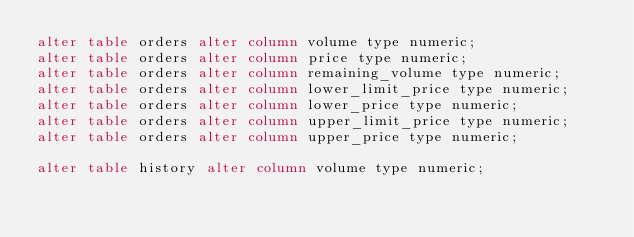Convert code to text. <code><loc_0><loc_0><loc_500><loc_500><_SQL_>alter table orders alter column volume type numeric;
alter table orders alter column price type numeric;
alter table orders alter column remaining_volume type numeric;
alter table orders alter column lower_limit_price type numeric;
alter table orders alter column lower_price type numeric;
alter table orders alter column upper_limit_price type numeric;
alter table orders alter column upper_price type numeric;

alter table history alter column volume type numeric;</code> 